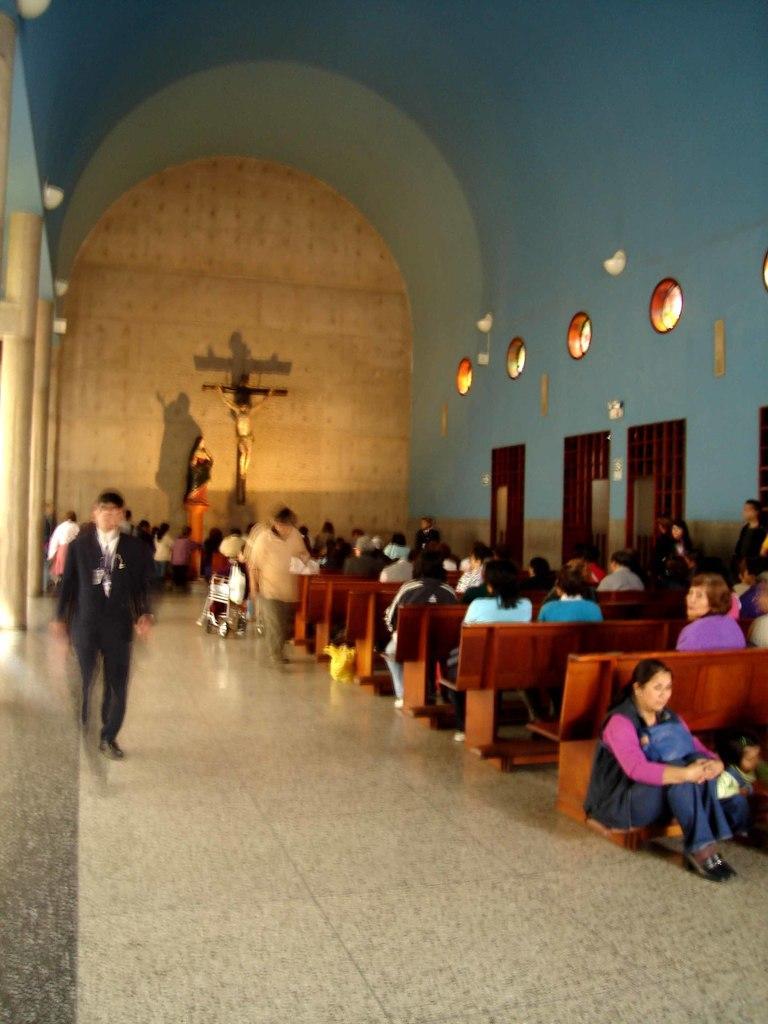Describe this image in one or two sentences. In this image we can see group of people sitting on chair. One person is wearing a coat is standing. In the background we can see two statues on the wall ,group of lights and doors. 